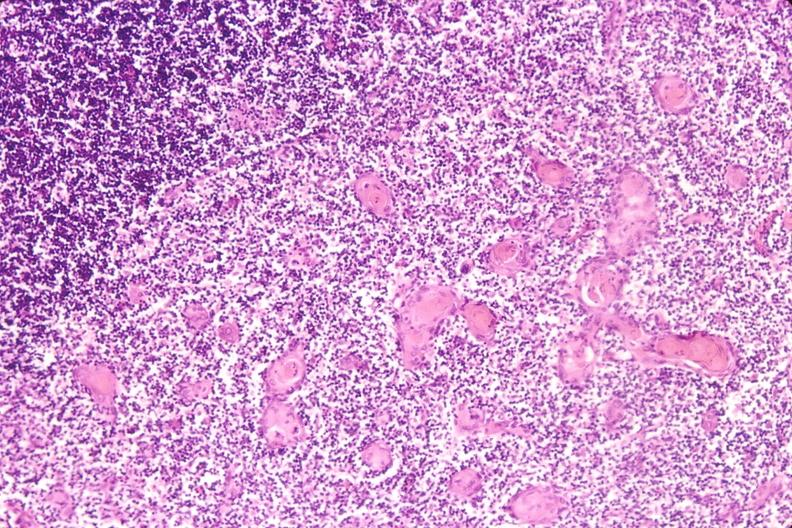s hematologic present?
Answer the question using a single word or phrase. Yes 